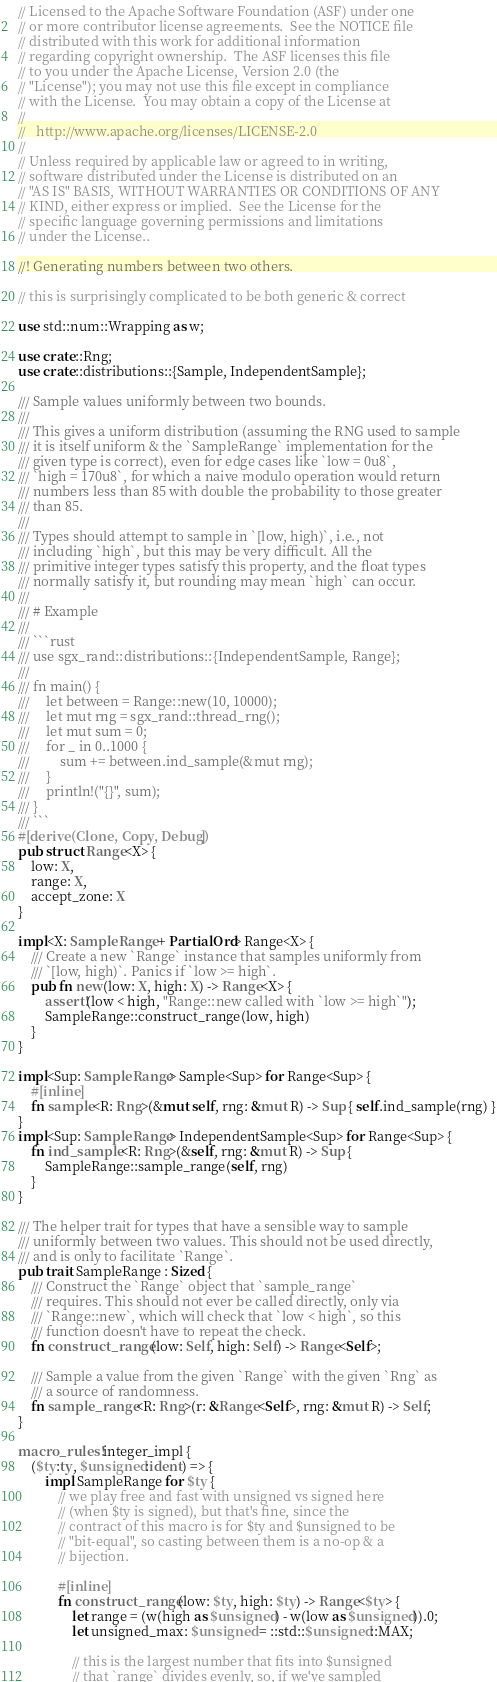<code> <loc_0><loc_0><loc_500><loc_500><_Rust_>// Licensed to the Apache Software Foundation (ASF) under one
// or more contributor license agreements.  See the NOTICE file
// distributed with this work for additional information
// regarding copyright ownership.  The ASF licenses this file
// to you under the Apache License, Version 2.0 (the
// "License"); you may not use this file except in compliance
// with the License.  You may obtain a copy of the License at
//
//   http://www.apache.org/licenses/LICENSE-2.0
//
// Unless required by applicable law or agreed to in writing,
// software distributed under the License is distributed on an
// "AS IS" BASIS, WITHOUT WARRANTIES OR CONDITIONS OF ANY
// KIND, either express or implied.  See the License for the
// specific language governing permissions and limitations
// under the License..

//! Generating numbers between two others.

// this is surprisingly complicated to be both generic & correct

use std::num::Wrapping as w;

use crate::Rng;
use crate::distributions::{Sample, IndependentSample};

/// Sample values uniformly between two bounds.
///
/// This gives a uniform distribution (assuming the RNG used to sample
/// it is itself uniform & the `SampleRange` implementation for the
/// given type is correct), even for edge cases like `low = 0u8`,
/// `high = 170u8`, for which a naive modulo operation would return
/// numbers less than 85 with double the probability to those greater
/// than 85.
///
/// Types should attempt to sample in `[low, high)`, i.e., not
/// including `high`, but this may be very difficult. All the
/// primitive integer types satisfy this property, and the float types
/// normally satisfy it, but rounding may mean `high` can occur.
///
/// # Example
///
/// ```rust
/// use sgx_rand::distributions::{IndependentSample, Range};
///
/// fn main() {
///     let between = Range::new(10, 10000);
///     let mut rng = sgx_rand::thread_rng();
///     let mut sum = 0;
///     for _ in 0..1000 {
///         sum += between.ind_sample(&mut rng);
///     }
///     println!("{}", sum);
/// }
/// ```
#[derive(Clone, Copy, Debug)]
pub struct Range<X> {
    low: X,
    range: X,
    accept_zone: X
}

impl<X: SampleRange + PartialOrd> Range<X> {
    /// Create a new `Range` instance that samples uniformly from
    /// `[low, high)`. Panics if `low >= high`.
    pub fn new(low: X, high: X) -> Range<X> {
        assert!(low < high, "Range::new called with `low >= high`");
        SampleRange::construct_range(low, high)
    }
}

impl<Sup: SampleRange> Sample<Sup> for Range<Sup> {
    #[inline]
    fn sample<R: Rng>(&mut self, rng: &mut R) -> Sup { self.ind_sample(rng) }
}
impl<Sup: SampleRange> IndependentSample<Sup> for Range<Sup> {
    fn ind_sample<R: Rng>(&self, rng: &mut R) -> Sup {
        SampleRange::sample_range(self, rng)
    }
}

/// The helper trait for types that have a sensible way to sample
/// uniformly between two values. This should not be used directly,
/// and is only to facilitate `Range`.
pub trait SampleRange : Sized {
    /// Construct the `Range` object that `sample_range`
    /// requires. This should not ever be called directly, only via
    /// `Range::new`, which will check that `low < high`, so this
    /// function doesn't have to repeat the check.
    fn construct_range(low: Self, high: Self) -> Range<Self>;

    /// Sample a value from the given `Range` with the given `Rng` as
    /// a source of randomness.
    fn sample_range<R: Rng>(r: &Range<Self>, rng: &mut R) -> Self;
}

macro_rules! integer_impl {
    ($ty:ty, $unsigned:ident) => {
        impl SampleRange for $ty {
            // we play free and fast with unsigned vs signed here
            // (when $ty is signed), but that's fine, since the
            // contract of this macro is for $ty and $unsigned to be
            // "bit-equal", so casting between them is a no-op & a
            // bijection.

            #[inline]
            fn construct_range(low: $ty, high: $ty) -> Range<$ty> {
                let range = (w(high as $unsigned) - w(low as $unsigned)).0;
                let unsigned_max: $unsigned = ::std::$unsigned::MAX;

                // this is the largest number that fits into $unsigned
                // that `range` divides evenly, so, if we've sampled</code> 